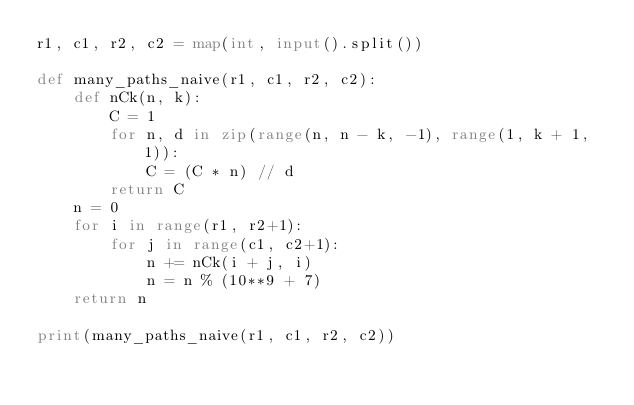Convert code to text. <code><loc_0><loc_0><loc_500><loc_500><_Python_>r1, c1, r2, c2 = map(int, input().split())

def many_paths_naive(r1, c1, r2, c2):
    def nCk(n, k):
        C = 1
        for n, d in zip(range(n, n - k, -1), range(1, k + 1, 1)):
            C = (C * n) // d
        return C
    n = 0
    for i in range(r1, r2+1):
        for j in range(c1, c2+1):
            n += nCk(i + j, i)
            n = n % (10**9 + 7)
    return n

print(many_paths_naive(r1, c1, r2, c2))
</code> 